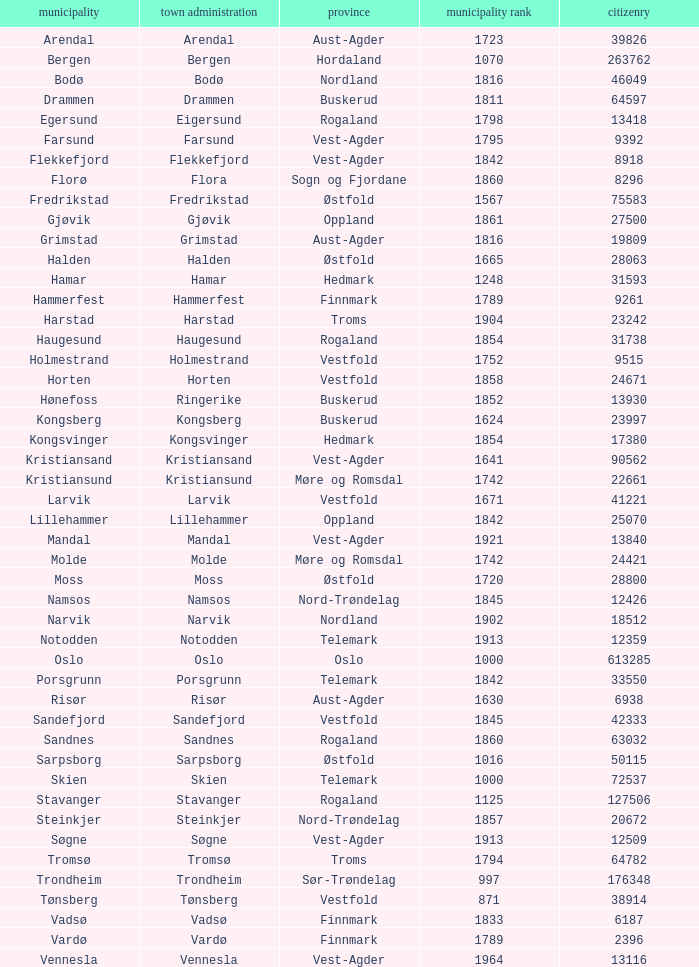Which municipalities located in the county of Finnmark have populations bigger than 6187.0? Hammerfest. 